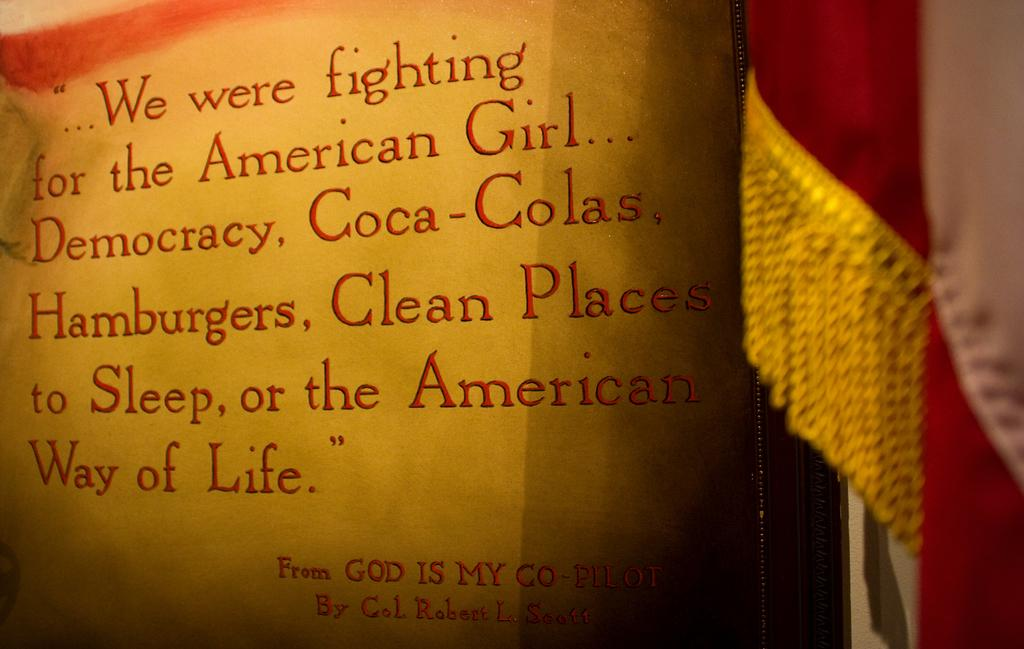<image>
Offer a succinct explanation of the picture presented. a quote from God is my co-pilot on a page 